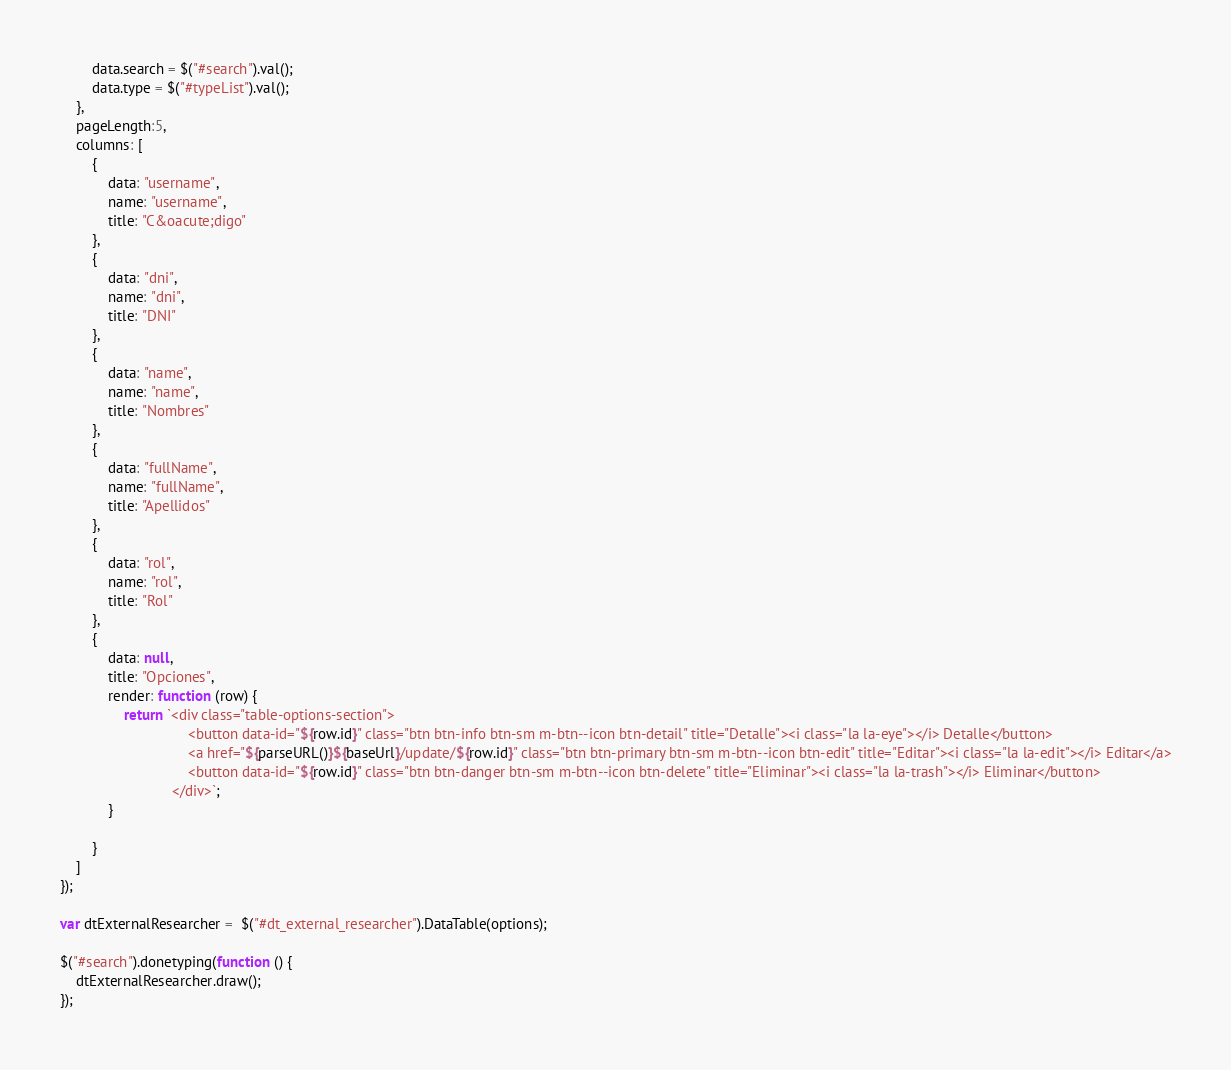Convert code to text. <code><loc_0><loc_0><loc_500><loc_500><_JavaScript_>        data.search = $("#search").val();
        data.type = $("#typeList").val();
    },
    pageLength:5,
    columns: [
        {
            data: "username",
            name: "username",
            title: "C&oacute;digo"
        },
        {
            data: "dni",
            name: "dni",
            title: "DNI"
        },
        {
            data: "name",
            name: "name",
            title: "Nombres"
        },
        {
            data: "fullName",
            name: "fullName",
            title: "Apellidos"
        },
        {
            data: "rol",
            name: "rol",
            title: "Rol"
        },
        {
            data: null,
            title: "Opciones",
            render: function (row) {
                return `<div class="table-options-section">
                                <button data-id="${row.id}" class="btn btn-info btn-sm m-btn--icon btn-detail" title="Detalle"><i class="la la-eye"></i> Detalle</button>
                                <a href="${parseURL()}${baseUrl}/update/${row.id}" class="btn btn-primary btn-sm m-btn--icon btn-edit" title="Editar"><i class="la la-edit"></i> Editar</a>
                                <button data-id="${row.id}" class="btn btn-danger btn-sm m-btn--icon btn-delete" title="Eliminar"><i class="la la-trash"></i> Eliminar</button>
                            </div>`;
            }

        }
    ]
});

var dtExternalResearcher =  $("#dt_external_researcher").DataTable(options);

$("#search").donetyping(function () {
    dtExternalResearcher.draw();
});
</code> 